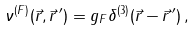<formula> <loc_0><loc_0><loc_500><loc_500>\nu ^ { ( F ) } ( \vec { r } , \vec { r } \, ^ { \prime } ) = g _ { F } \delta ^ { ( 3 ) } ( \vec { r } - \vec { r } \, ^ { \prime } ) \, ,</formula> 